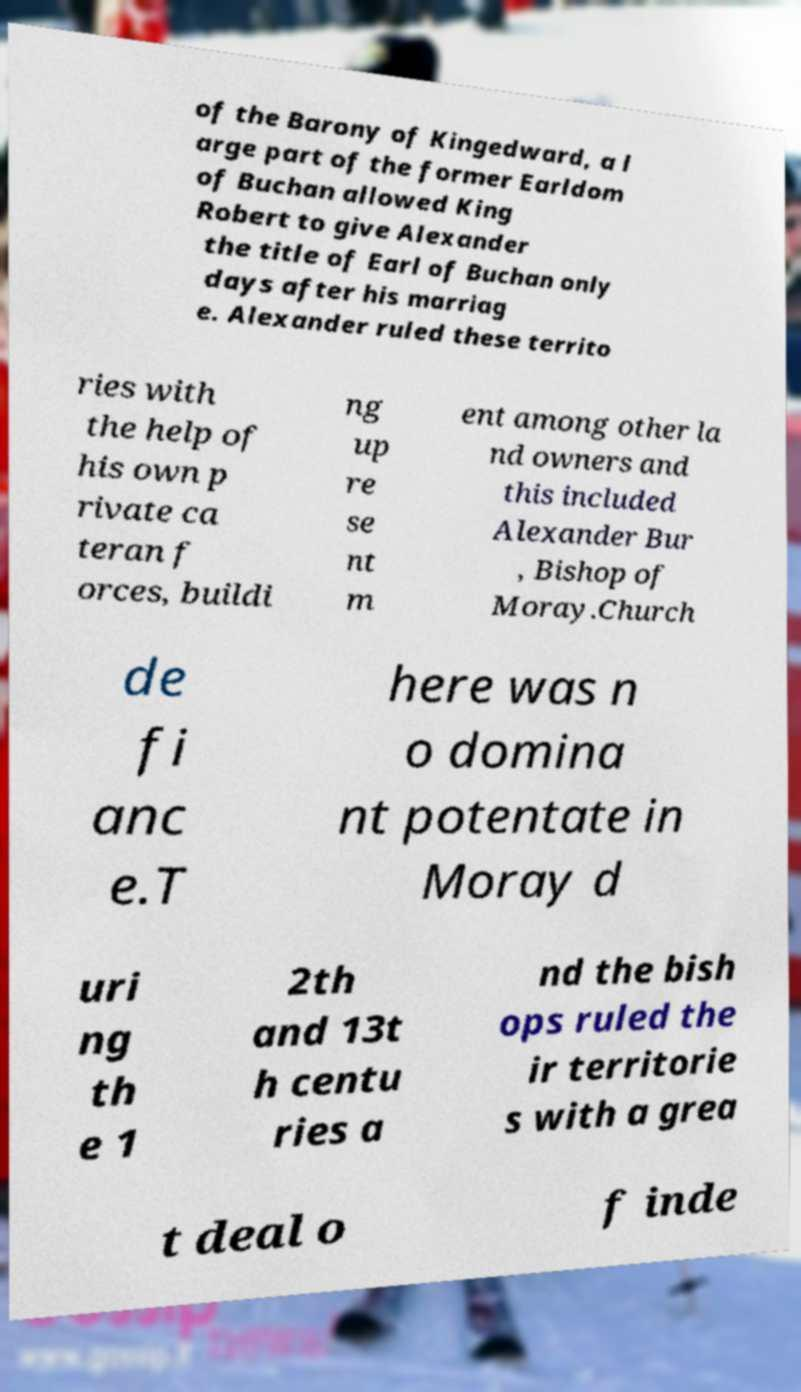What messages or text are displayed in this image? I need them in a readable, typed format. of the Barony of Kingedward, a l arge part of the former Earldom of Buchan allowed King Robert to give Alexander the title of Earl of Buchan only days after his marriag e. Alexander ruled these territo ries with the help of his own p rivate ca teran f orces, buildi ng up re se nt m ent among other la nd owners and this included Alexander Bur , Bishop of Moray.Church de fi anc e.T here was n o domina nt potentate in Moray d uri ng th e 1 2th and 13t h centu ries a nd the bish ops ruled the ir territorie s with a grea t deal o f inde 